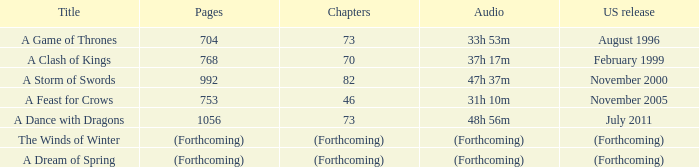Parse the full table. {'header': ['Title', 'Pages', 'Chapters', 'Audio', 'US release'], 'rows': [['A Game of Thrones', '704', '73', '33h 53m', 'August 1996'], ['A Clash of Kings', '768', '70', '37h 17m', 'February 1999'], ['A Storm of Swords', '992', '82', '47h 37m', 'November 2000'], ['A Feast for Crows', '753', '46', '31h 10m', 'November 2005'], ['A Dance with Dragons', '1056', '73', '48h 56m', 'July 2011'], ['The Winds of Winter', '(Forthcoming)', '(Forthcoming)', '(Forthcoming)', '(Forthcoming)'], ['A Dream of Spring', '(Forthcoming)', '(Forthcoming)', '(Forthcoming)', '(Forthcoming)']]} Which audio has a Title of a storm of swords? 47h 37m. 